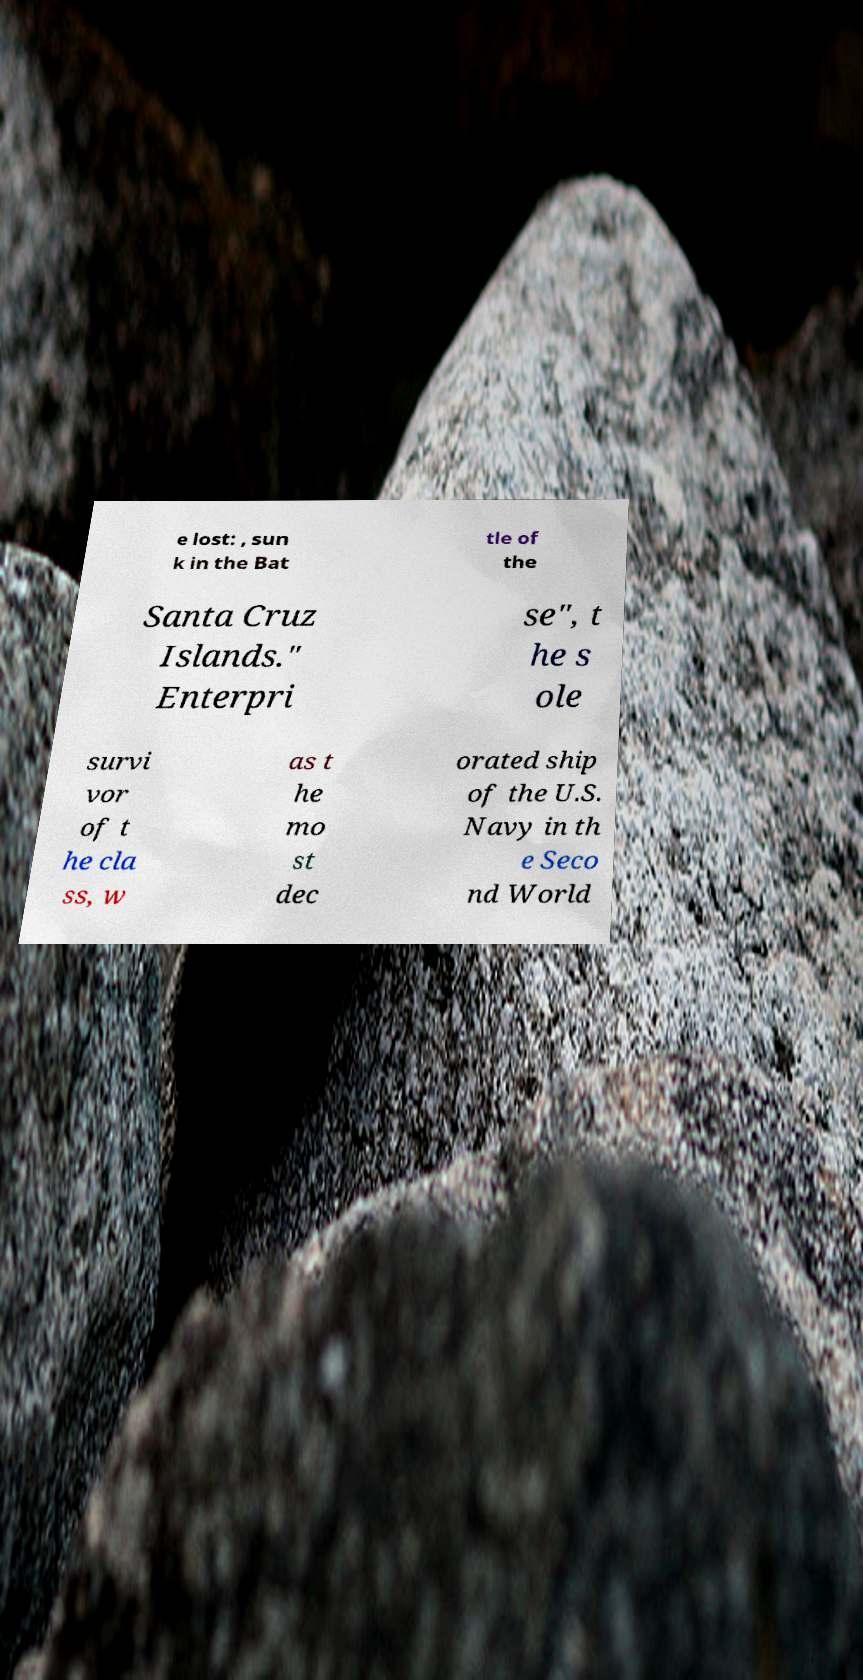Can you accurately transcribe the text from the provided image for me? e lost: , sun k in the Bat tle of the Santa Cruz Islands." Enterpri se", t he s ole survi vor of t he cla ss, w as t he mo st dec orated ship of the U.S. Navy in th e Seco nd World 